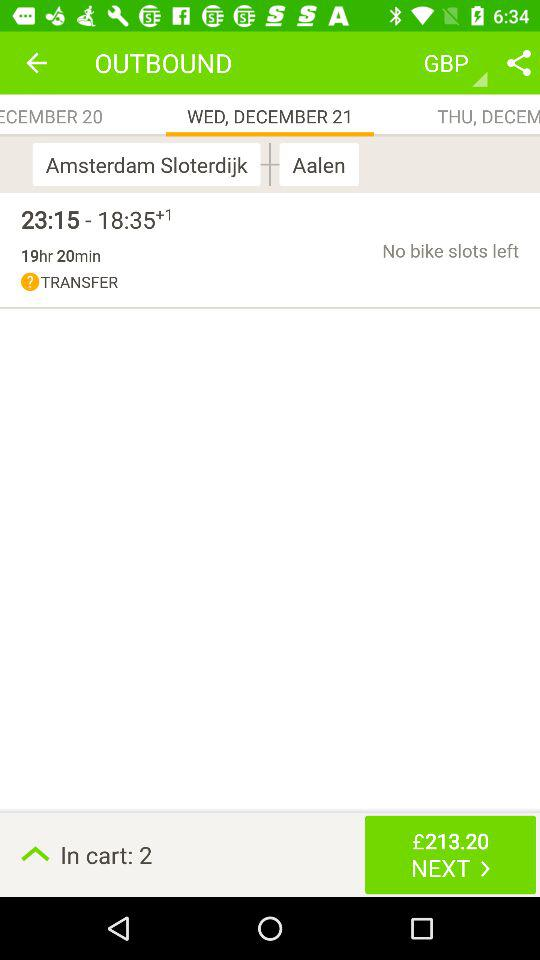What is the amount? The amount is £213.20. 